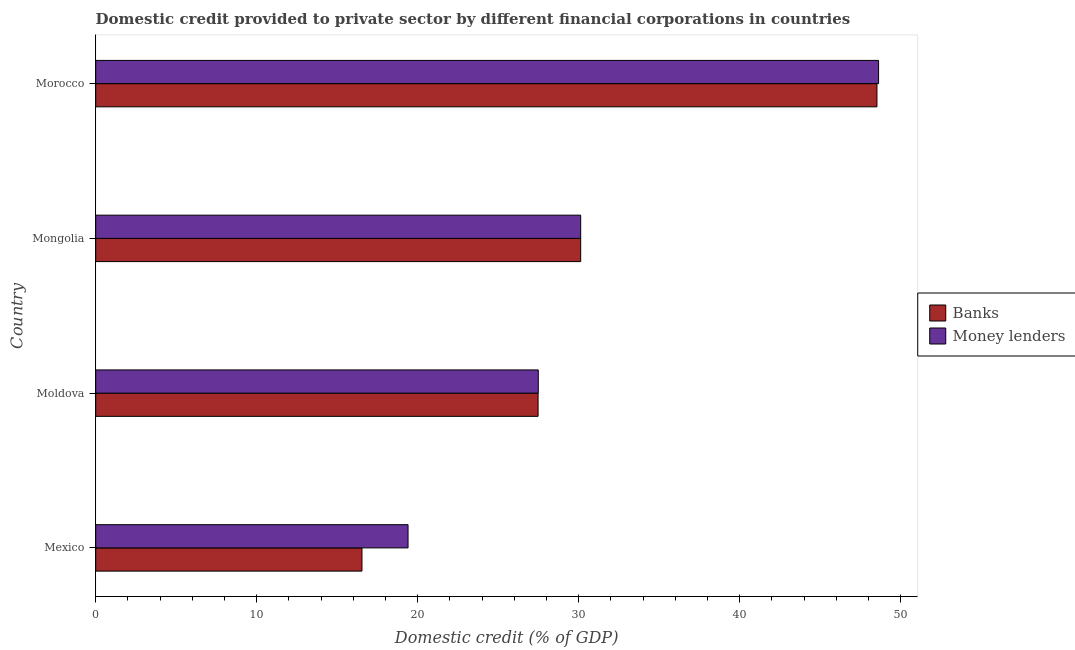Are the number of bars on each tick of the Y-axis equal?
Your answer should be very brief. Yes. How many bars are there on the 1st tick from the top?
Ensure brevity in your answer.  2. What is the label of the 1st group of bars from the top?
Keep it short and to the point. Morocco. What is the domestic credit provided by money lenders in Moldova?
Keep it short and to the point. 27.48. Across all countries, what is the maximum domestic credit provided by banks?
Keep it short and to the point. 48.52. Across all countries, what is the minimum domestic credit provided by banks?
Provide a short and direct response. 16.54. In which country was the domestic credit provided by banks maximum?
Offer a terse response. Morocco. What is the total domestic credit provided by money lenders in the graph?
Provide a short and direct response. 125.62. What is the difference between the domestic credit provided by banks in Mexico and that in Mongolia?
Your answer should be compact. -13.58. What is the difference between the domestic credit provided by banks in Moldova and the domestic credit provided by money lenders in Morocco?
Provide a succinct answer. -21.15. What is the average domestic credit provided by banks per country?
Give a very brief answer. 30.66. What is the difference between the domestic credit provided by banks and domestic credit provided by money lenders in Mexico?
Provide a succinct answer. -2.86. What is the ratio of the domestic credit provided by banks in Mexico to that in Mongolia?
Provide a short and direct response. 0.55. Is the domestic credit provided by banks in Moldova less than that in Mongolia?
Offer a very short reply. Yes. What is the difference between the highest and the second highest domestic credit provided by money lenders?
Your answer should be compact. 18.5. What is the difference between the highest and the lowest domestic credit provided by banks?
Ensure brevity in your answer.  31.98. In how many countries, is the domestic credit provided by banks greater than the average domestic credit provided by banks taken over all countries?
Give a very brief answer. 1. What does the 2nd bar from the top in Mongolia represents?
Ensure brevity in your answer.  Banks. What does the 2nd bar from the bottom in Moldova represents?
Keep it short and to the point. Money lenders. How many bars are there?
Give a very brief answer. 8. What is the difference between two consecutive major ticks on the X-axis?
Provide a short and direct response. 10. Does the graph contain grids?
Offer a very short reply. No. Where does the legend appear in the graph?
Provide a succinct answer. Center right. How many legend labels are there?
Your response must be concise. 2. What is the title of the graph?
Offer a terse response. Domestic credit provided to private sector by different financial corporations in countries. What is the label or title of the X-axis?
Your response must be concise. Domestic credit (% of GDP). What is the Domestic credit (% of GDP) of Banks in Mexico?
Give a very brief answer. 16.54. What is the Domestic credit (% of GDP) of Money lenders in Mexico?
Offer a terse response. 19.4. What is the Domestic credit (% of GDP) in Banks in Moldova?
Offer a terse response. 27.47. What is the Domestic credit (% of GDP) of Money lenders in Moldova?
Ensure brevity in your answer.  27.48. What is the Domestic credit (% of GDP) of Banks in Mongolia?
Provide a succinct answer. 30.12. What is the Domestic credit (% of GDP) in Money lenders in Mongolia?
Your response must be concise. 30.12. What is the Domestic credit (% of GDP) in Banks in Morocco?
Your answer should be compact. 48.52. What is the Domestic credit (% of GDP) of Money lenders in Morocco?
Keep it short and to the point. 48.62. Across all countries, what is the maximum Domestic credit (% of GDP) in Banks?
Ensure brevity in your answer.  48.52. Across all countries, what is the maximum Domestic credit (% of GDP) of Money lenders?
Ensure brevity in your answer.  48.62. Across all countries, what is the minimum Domestic credit (% of GDP) in Banks?
Give a very brief answer. 16.54. Across all countries, what is the minimum Domestic credit (% of GDP) of Money lenders?
Offer a very short reply. 19.4. What is the total Domestic credit (% of GDP) in Banks in the graph?
Provide a short and direct response. 122.65. What is the total Domestic credit (% of GDP) in Money lenders in the graph?
Keep it short and to the point. 125.62. What is the difference between the Domestic credit (% of GDP) in Banks in Mexico and that in Moldova?
Give a very brief answer. -10.94. What is the difference between the Domestic credit (% of GDP) in Money lenders in Mexico and that in Moldova?
Offer a very short reply. -8.09. What is the difference between the Domestic credit (% of GDP) in Banks in Mexico and that in Mongolia?
Make the answer very short. -13.58. What is the difference between the Domestic credit (% of GDP) of Money lenders in Mexico and that in Mongolia?
Provide a short and direct response. -10.72. What is the difference between the Domestic credit (% of GDP) in Banks in Mexico and that in Morocco?
Offer a very short reply. -31.98. What is the difference between the Domestic credit (% of GDP) in Money lenders in Mexico and that in Morocco?
Offer a terse response. -29.22. What is the difference between the Domestic credit (% of GDP) in Banks in Moldova and that in Mongolia?
Keep it short and to the point. -2.65. What is the difference between the Domestic credit (% of GDP) of Money lenders in Moldova and that in Mongolia?
Your answer should be very brief. -2.63. What is the difference between the Domestic credit (% of GDP) of Banks in Moldova and that in Morocco?
Offer a very short reply. -21.05. What is the difference between the Domestic credit (% of GDP) in Money lenders in Moldova and that in Morocco?
Your response must be concise. -21.14. What is the difference between the Domestic credit (% of GDP) of Banks in Mongolia and that in Morocco?
Offer a very short reply. -18.4. What is the difference between the Domestic credit (% of GDP) of Money lenders in Mongolia and that in Morocco?
Keep it short and to the point. -18.5. What is the difference between the Domestic credit (% of GDP) of Banks in Mexico and the Domestic credit (% of GDP) of Money lenders in Moldova?
Offer a terse response. -10.95. What is the difference between the Domestic credit (% of GDP) of Banks in Mexico and the Domestic credit (% of GDP) of Money lenders in Mongolia?
Make the answer very short. -13.58. What is the difference between the Domestic credit (% of GDP) in Banks in Mexico and the Domestic credit (% of GDP) in Money lenders in Morocco?
Give a very brief answer. -32.08. What is the difference between the Domestic credit (% of GDP) of Banks in Moldova and the Domestic credit (% of GDP) of Money lenders in Mongolia?
Offer a terse response. -2.65. What is the difference between the Domestic credit (% of GDP) of Banks in Moldova and the Domestic credit (% of GDP) of Money lenders in Morocco?
Offer a terse response. -21.15. What is the difference between the Domestic credit (% of GDP) in Banks in Mongolia and the Domestic credit (% of GDP) in Money lenders in Morocco?
Provide a short and direct response. -18.5. What is the average Domestic credit (% of GDP) in Banks per country?
Make the answer very short. 30.66. What is the average Domestic credit (% of GDP) in Money lenders per country?
Offer a very short reply. 31.41. What is the difference between the Domestic credit (% of GDP) in Banks and Domestic credit (% of GDP) in Money lenders in Mexico?
Provide a short and direct response. -2.86. What is the difference between the Domestic credit (% of GDP) of Banks and Domestic credit (% of GDP) of Money lenders in Moldova?
Give a very brief answer. -0.01. What is the difference between the Domestic credit (% of GDP) in Banks and Domestic credit (% of GDP) in Money lenders in Morocco?
Provide a short and direct response. -0.1. What is the ratio of the Domestic credit (% of GDP) of Banks in Mexico to that in Moldova?
Give a very brief answer. 0.6. What is the ratio of the Domestic credit (% of GDP) of Money lenders in Mexico to that in Moldova?
Give a very brief answer. 0.71. What is the ratio of the Domestic credit (% of GDP) in Banks in Mexico to that in Mongolia?
Give a very brief answer. 0.55. What is the ratio of the Domestic credit (% of GDP) of Money lenders in Mexico to that in Mongolia?
Your answer should be very brief. 0.64. What is the ratio of the Domestic credit (% of GDP) of Banks in Mexico to that in Morocco?
Ensure brevity in your answer.  0.34. What is the ratio of the Domestic credit (% of GDP) in Money lenders in Mexico to that in Morocco?
Offer a very short reply. 0.4. What is the ratio of the Domestic credit (% of GDP) of Banks in Moldova to that in Mongolia?
Provide a short and direct response. 0.91. What is the ratio of the Domestic credit (% of GDP) in Money lenders in Moldova to that in Mongolia?
Offer a very short reply. 0.91. What is the ratio of the Domestic credit (% of GDP) in Banks in Moldova to that in Morocco?
Your answer should be very brief. 0.57. What is the ratio of the Domestic credit (% of GDP) of Money lenders in Moldova to that in Morocco?
Offer a very short reply. 0.57. What is the ratio of the Domestic credit (% of GDP) of Banks in Mongolia to that in Morocco?
Your answer should be very brief. 0.62. What is the ratio of the Domestic credit (% of GDP) of Money lenders in Mongolia to that in Morocco?
Provide a succinct answer. 0.62. What is the difference between the highest and the second highest Domestic credit (% of GDP) of Banks?
Provide a succinct answer. 18.4. What is the difference between the highest and the second highest Domestic credit (% of GDP) in Money lenders?
Provide a succinct answer. 18.5. What is the difference between the highest and the lowest Domestic credit (% of GDP) of Banks?
Your answer should be very brief. 31.98. What is the difference between the highest and the lowest Domestic credit (% of GDP) of Money lenders?
Give a very brief answer. 29.22. 